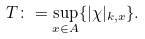<formula> <loc_0><loc_0><loc_500><loc_500>T \colon = \underset { x \in A } { \sup } \{ | \chi | _ { k , x } \} .</formula> 